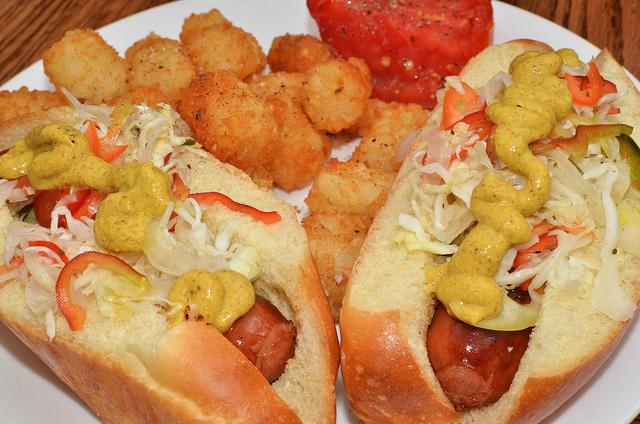What is the pattern on the plate?
Quick response, please. Solid. What color is the plate?
Answer briefly. White. Does this person like mustard?
Quick response, please. Yes. Is anything made of potato?
Concise answer only. Yes. Is there cheese on the hot dog?
Write a very short answer. No. Are there tomato slices on this dish?
Keep it brief. Yes. 